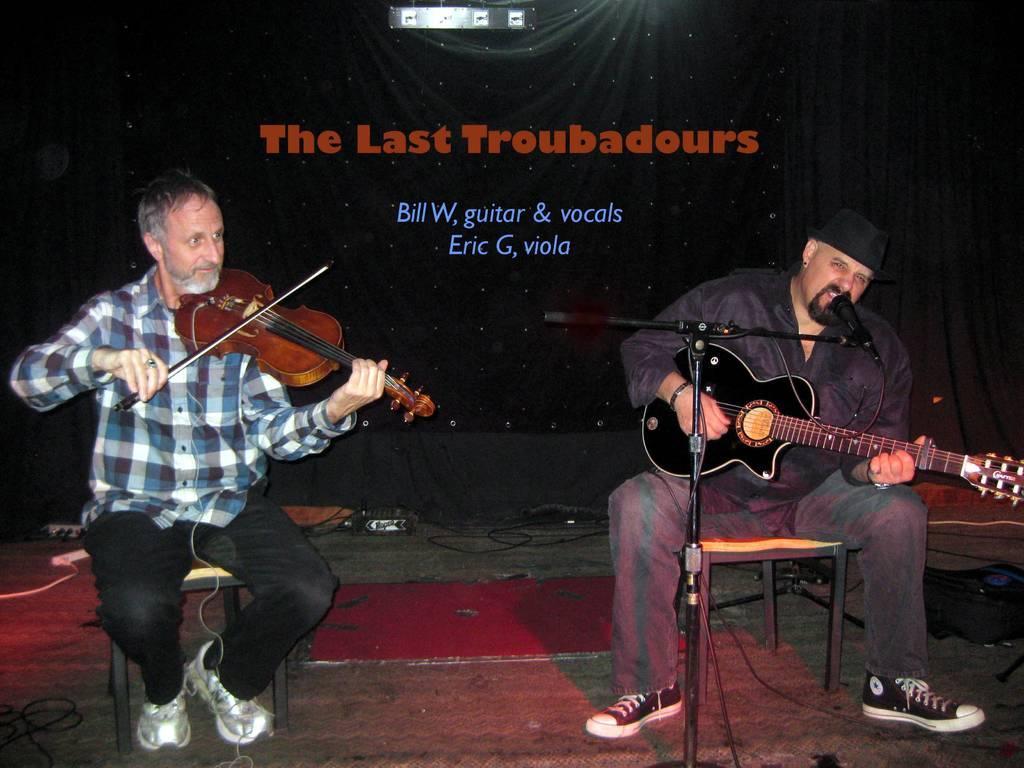Describe this image in one or two sentences. There is a person sitting on a chair and he is playing a guitar. There is another person sitting on a chair and he is on the right side. He is playing a guitar and he is singing on a microphone. 